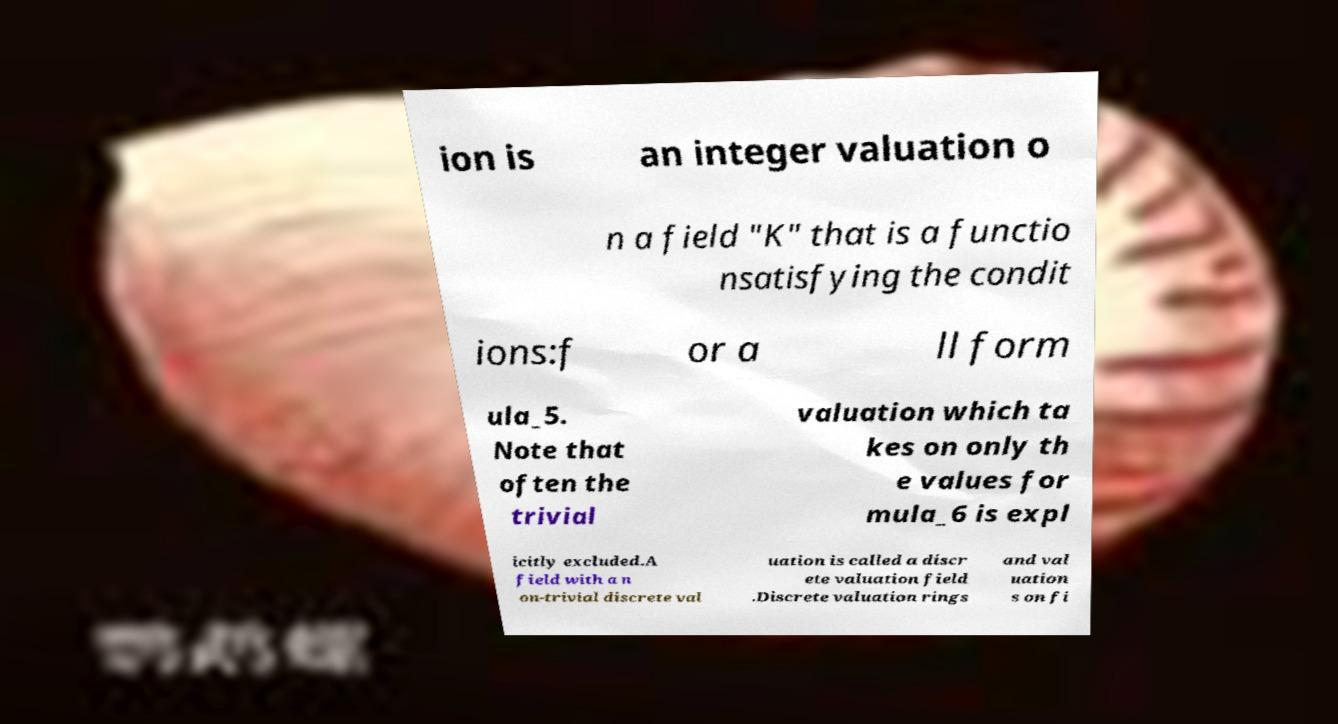Could you extract and type out the text from this image? ion is an integer valuation o n a field "K" that is a functio nsatisfying the condit ions:f or a ll form ula_5. Note that often the trivial valuation which ta kes on only th e values for mula_6 is expl icitly excluded.A field with a n on-trivial discrete val uation is called a discr ete valuation field .Discrete valuation rings and val uation s on fi 